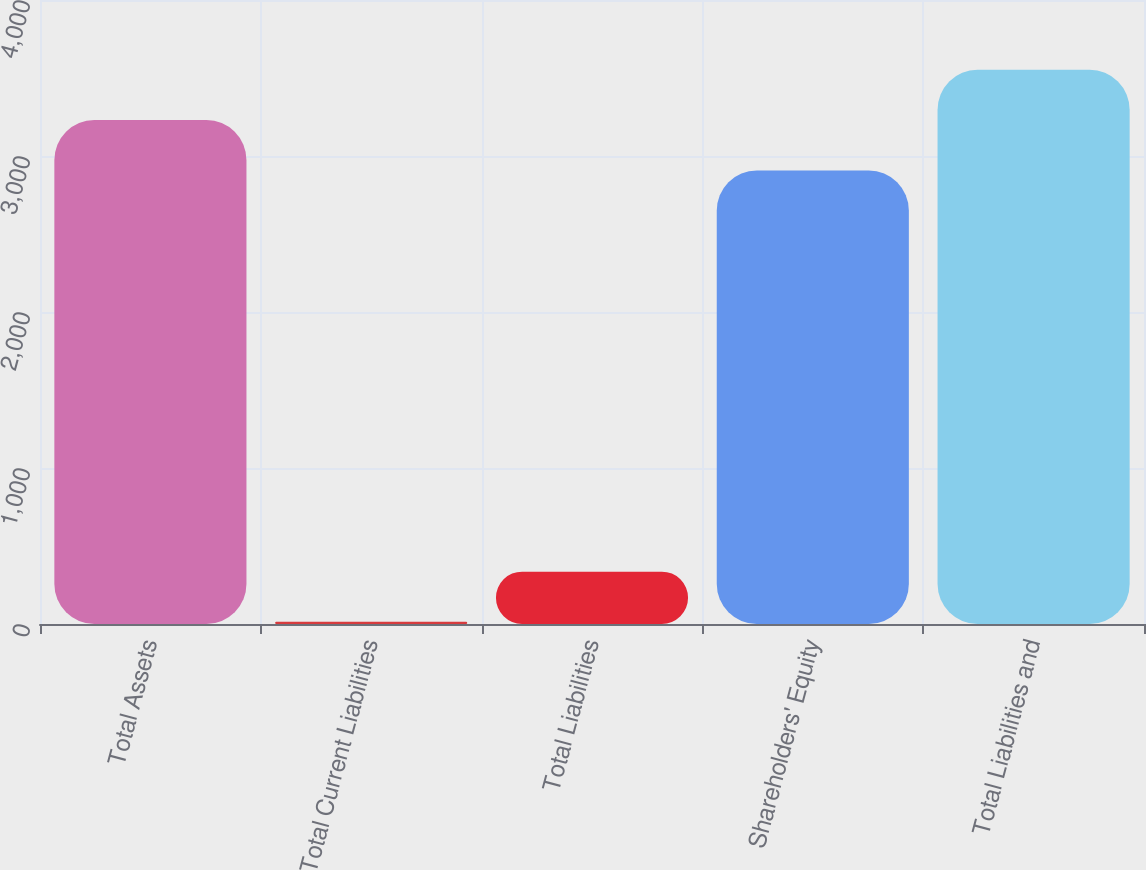Convert chart to OTSL. <chart><loc_0><loc_0><loc_500><loc_500><bar_chart><fcel>Total Assets<fcel>Total Current Liabilities<fcel>Total Liabilities<fcel>Shareholders' Equity<fcel>Total Liabilities and<nl><fcel>3231<fcel>14<fcel>335.7<fcel>2907<fcel>3552.7<nl></chart> 